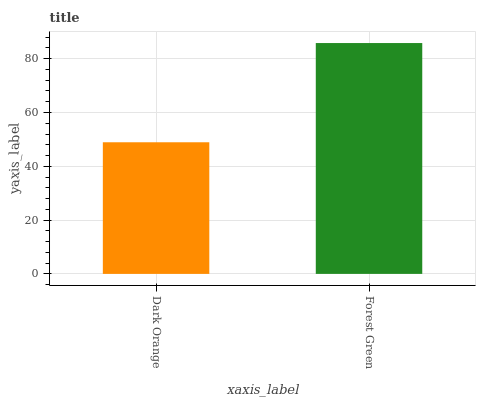Is Dark Orange the minimum?
Answer yes or no. Yes. Is Forest Green the maximum?
Answer yes or no. Yes. Is Forest Green the minimum?
Answer yes or no. No. Is Forest Green greater than Dark Orange?
Answer yes or no. Yes. Is Dark Orange less than Forest Green?
Answer yes or no. Yes. Is Dark Orange greater than Forest Green?
Answer yes or no. No. Is Forest Green less than Dark Orange?
Answer yes or no. No. Is Forest Green the high median?
Answer yes or no. Yes. Is Dark Orange the low median?
Answer yes or no. Yes. Is Dark Orange the high median?
Answer yes or no. No. Is Forest Green the low median?
Answer yes or no. No. 